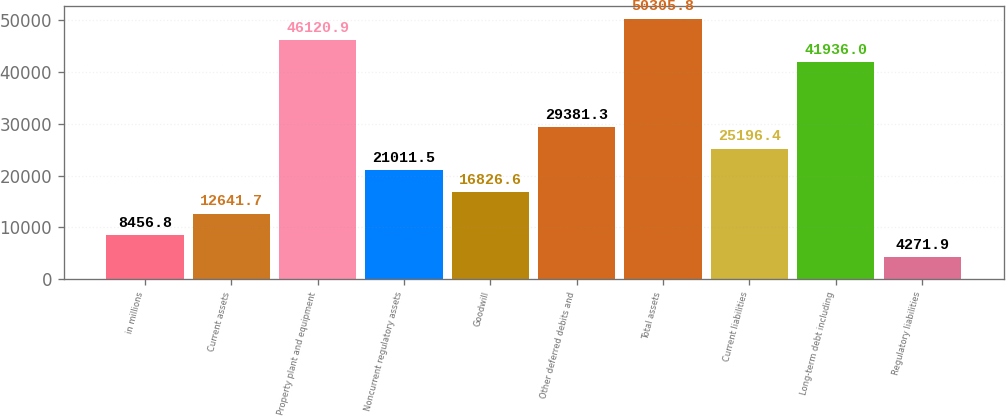<chart> <loc_0><loc_0><loc_500><loc_500><bar_chart><fcel>in millions<fcel>Current assets<fcel>Property plant and equipment<fcel>Noncurrent regulatory assets<fcel>Goodwill<fcel>Other deferred debits and<fcel>Total assets<fcel>Current liabilities<fcel>Long-term debt including<fcel>Regulatory liabilities<nl><fcel>8456.8<fcel>12641.7<fcel>46120.9<fcel>21011.5<fcel>16826.6<fcel>29381.3<fcel>50305.8<fcel>25196.4<fcel>41936<fcel>4271.9<nl></chart> 